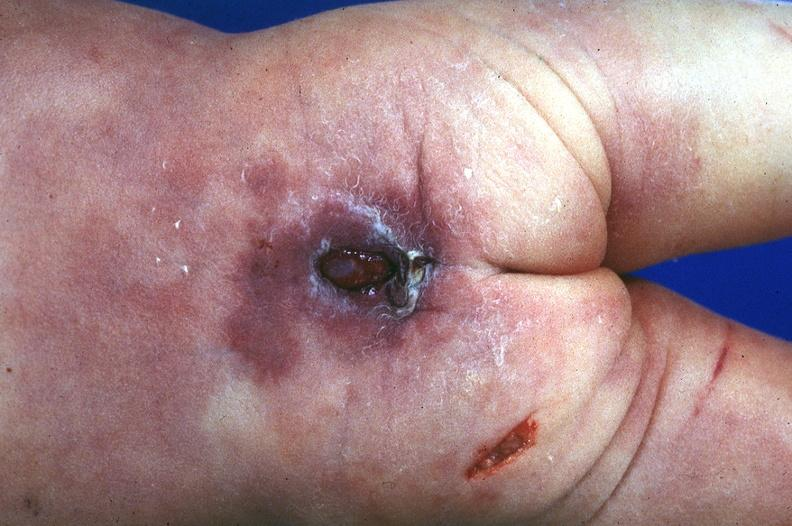does this image show neural tube defect?
Answer the question using a single word or phrase. Yes 